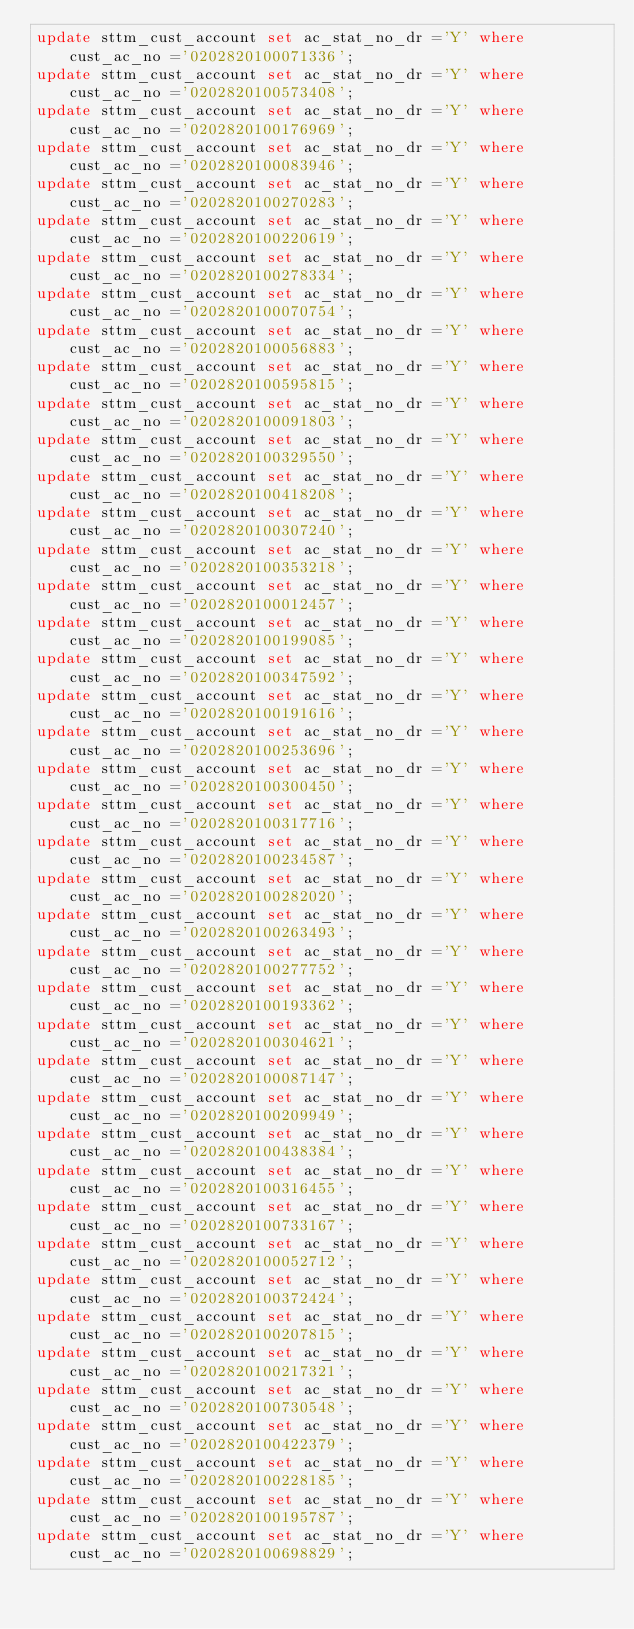Convert code to text. <code><loc_0><loc_0><loc_500><loc_500><_SQL_>update sttm_cust_account set ac_stat_no_dr ='Y' where cust_ac_no ='0202820100071336';
update sttm_cust_account set ac_stat_no_dr ='Y' where cust_ac_no ='0202820100573408';
update sttm_cust_account set ac_stat_no_dr ='Y' where cust_ac_no ='0202820100176969';
update sttm_cust_account set ac_stat_no_dr ='Y' where cust_ac_no ='0202820100083946';
update sttm_cust_account set ac_stat_no_dr ='Y' where cust_ac_no ='0202820100270283';
update sttm_cust_account set ac_stat_no_dr ='Y' where cust_ac_no ='0202820100220619';
update sttm_cust_account set ac_stat_no_dr ='Y' where cust_ac_no ='0202820100278334';
update sttm_cust_account set ac_stat_no_dr ='Y' where cust_ac_no ='0202820100070754';
update sttm_cust_account set ac_stat_no_dr ='Y' where cust_ac_no ='0202820100056883';
update sttm_cust_account set ac_stat_no_dr ='Y' where cust_ac_no ='0202820100595815';
update sttm_cust_account set ac_stat_no_dr ='Y' where cust_ac_no ='0202820100091803';
update sttm_cust_account set ac_stat_no_dr ='Y' where cust_ac_no ='0202820100329550';
update sttm_cust_account set ac_stat_no_dr ='Y' where cust_ac_no ='0202820100418208';
update sttm_cust_account set ac_stat_no_dr ='Y' where cust_ac_no ='0202820100307240';
update sttm_cust_account set ac_stat_no_dr ='Y' where cust_ac_no ='0202820100353218';
update sttm_cust_account set ac_stat_no_dr ='Y' where cust_ac_no ='0202820100012457';
update sttm_cust_account set ac_stat_no_dr ='Y' where cust_ac_no ='0202820100199085';
update sttm_cust_account set ac_stat_no_dr ='Y' where cust_ac_no ='0202820100347592';
update sttm_cust_account set ac_stat_no_dr ='Y' where cust_ac_no ='0202820100191616';
update sttm_cust_account set ac_stat_no_dr ='Y' where cust_ac_no ='0202820100253696';
update sttm_cust_account set ac_stat_no_dr ='Y' where cust_ac_no ='0202820100300450';
update sttm_cust_account set ac_stat_no_dr ='Y' where cust_ac_no ='0202820100317716';
update sttm_cust_account set ac_stat_no_dr ='Y' where cust_ac_no ='0202820100234587';
update sttm_cust_account set ac_stat_no_dr ='Y' where cust_ac_no ='0202820100282020';
update sttm_cust_account set ac_stat_no_dr ='Y' where cust_ac_no ='0202820100263493';
update sttm_cust_account set ac_stat_no_dr ='Y' where cust_ac_no ='0202820100277752';
update sttm_cust_account set ac_stat_no_dr ='Y' where cust_ac_no ='0202820100193362';
update sttm_cust_account set ac_stat_no_dr ='Y' where cust_ac_no ='0202820100304621';
update sttm_cust_account set ac_stat_no_dr ='Y' where cust_ac_no ='0202820100087147';
update sttm_cust_account set ac_stat_no_dr ='Y' where cust_ac_no ='0202820100209949';
update sttm_cust_account set ac_stat_no_dr ='Y' where cust_ac_no ='0202820100438384';
update sttm_cust_account set ac_stat_no_dr ='Y' where cust_ac_no ='0202820100316455';
update sttm_cust_account set ac_stat_no_dr ='Y' where cust_ac_no ='0202820100733167';
update sttm_cust_account set ac_stat_no_dr ='Y' where cust_ac_no ='0202820100052712';
update sttm_cust_account set ac_stat_no_dr ='Y' where cust_ac_no ='0202820100372424';
update sttm_cust_account set ac_stat_no_dr ='Y' where cust_ac_no ='0202820100207815';
update sttm_cust_account set ac_stat_no_dr ='Y' where cust_ac_no ='0202820100217321';
update sttm_cust_account set ac_stat_no_dr ='Y' where cust_ac_no ='0202820100730548';
update sttm_cust_account set ac_stat_no_dr ='Y' where cust_ac_no ='0202820100422379';
update sttm_cust_account set ac_stat_no_dr ='Y' where cust_ac_no ='0202820100228185';
update sttm_cust_account set ac_stat_no_dr ='Y' where cust_ac_no ='0202820100195787';
update sttm_cust_account set ac_stat_no_dr ='Y' where cust_ac_no ='0202820100698829';</code> 